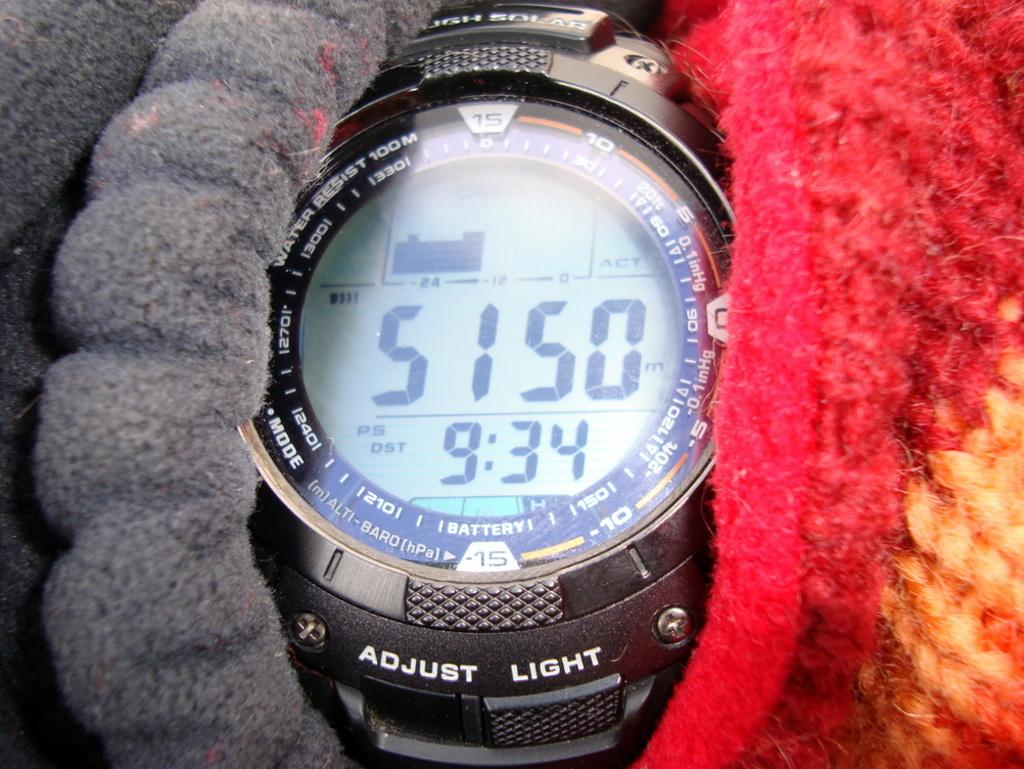<image>
Offer a succinct explanation of the picture presented. A digital watch that is water resistant up to 100 m shows the time as 9:34 and altitiude as  5150 m. 